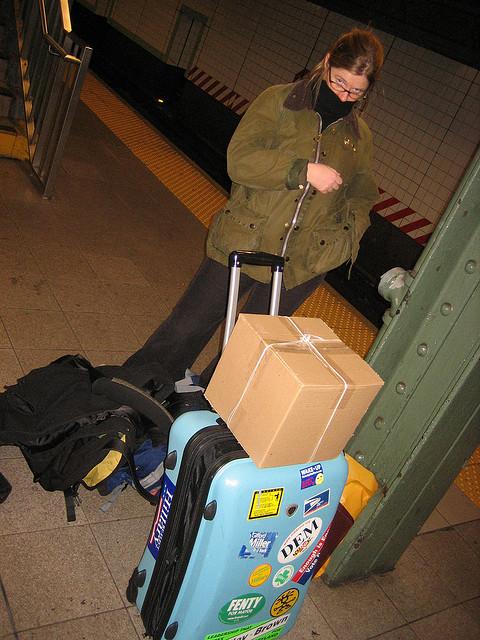Is the woman cold?
Keep it brief. Yes. What shade of blue is that luggage?
Give a very brief answer. Light. What is tied around the cardboard box?
Answer briefly. String. 